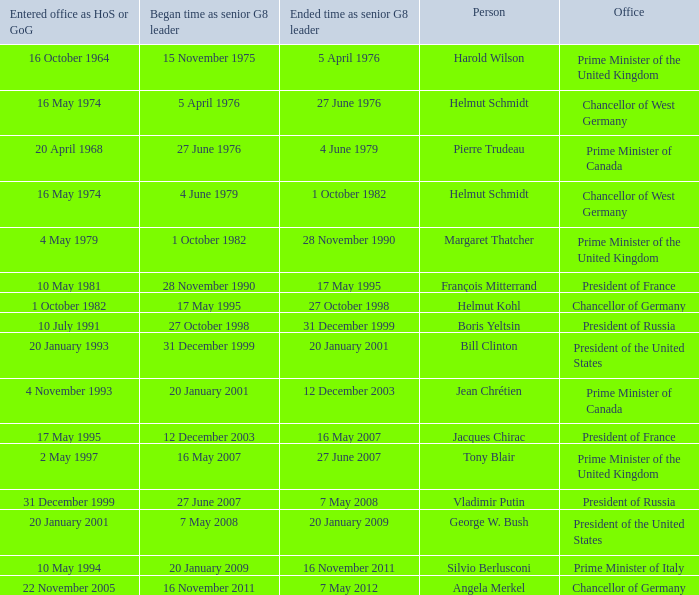When did the italian prime minister assume office? 10 May 1994. 